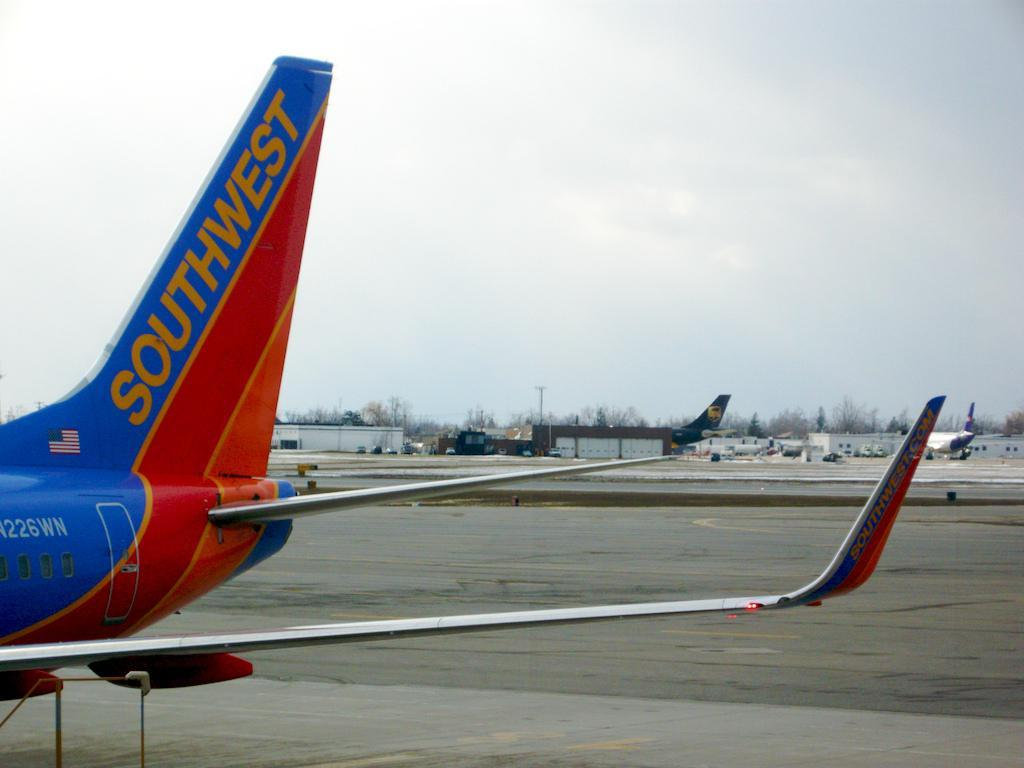<image>
Render a clear and concise summary of the photo. The tail of a Southwest Airlines plane is shown on the runway. 